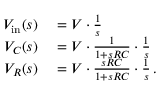Convert formula to latex. <formula><loc_0><loc_0><loc_500><loc_500>\begin{array} { r l } { V _ { i n } ( s ) } & = V \cdot { \frac { 1 } { s } } } \\ { V _ { C } ( s ) } & = V \cdot { \frac { 1 } { 1 + s R C } } \cdot { \frac { 1 } { s } } } \\ { V _ { R } ( s ) } & = V \cdot { \frac { s R C } { 1 + s R C } } \cdot { \frac { 1 } { s } } \, . } \end{array}</formula> 